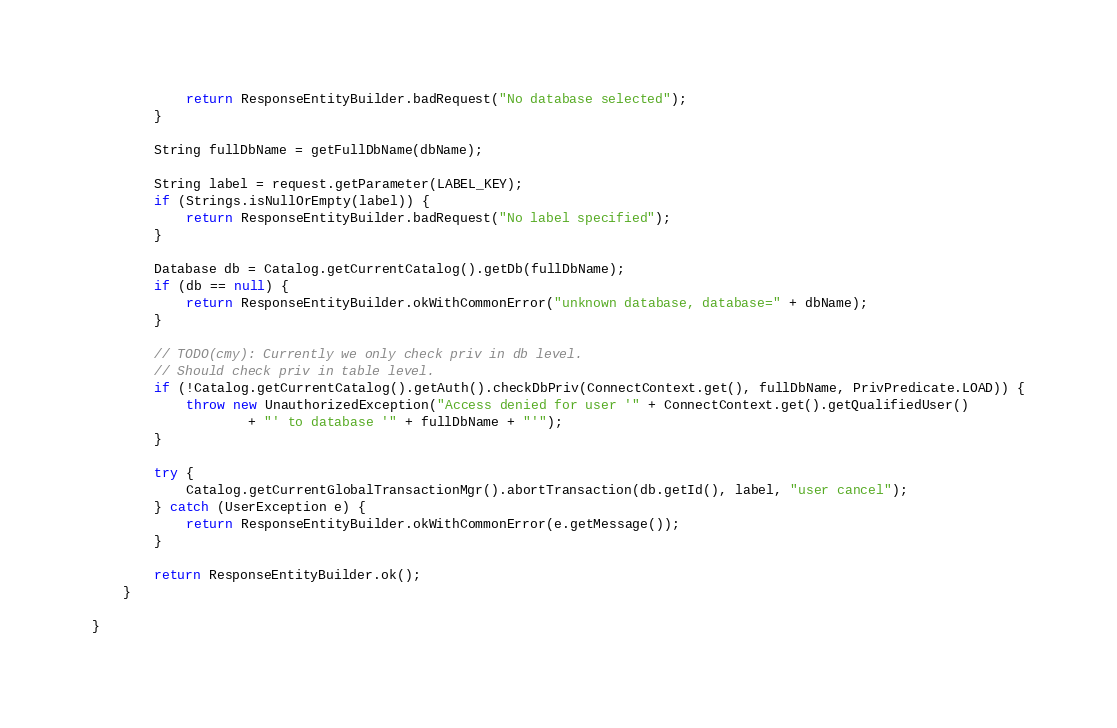Convert code to text. <code><loc_0><loc_0><loc_500><loc_500><_Java_>            return ResponseEntityBuilder.badRequest("No database selected");
        }

        String fullDbName = getFullDbName(dbName);

        String label = request.getParameter(LABEL_KEY);
        if (Strings.isNullOrEmpty(label)) {
            return ResponseEntityBuilder.badRequest("No label specified");
        }

        Database db = Catalog.getCurrentCatalog().getDb(fullDbName);
        if (db == null) {
            return ResponseEntityBuilder.okWithCommonError("unknown database, database=" + dbName);
        }

        // TODO(cmy): Currently we only check priv in db level.
        // Should check priv in table level.
        if (!Catalog.getCurrentCatalog().getAuth().checkDbPriv(ConnectContext.get(), fullDbName, PrivPredicate.LOAD)) {
            throw new UnauthorizedException("Access denied for user '" + ConnectContext.get().getQualifiedUser()
                    + "' to database '" + fullDbName + "'");
        }

        try {
            Catalog.getCurrentGlobalTransactionMgr().abortTransaction(db.getId(), label, "user cancel");
        } catch (UserException e) {
            return ResponseEntityBuilder.okWithCommonError(e.getMessage());
        }

        return ResponseEntityBuilder.ok();
    }

}
</code> 